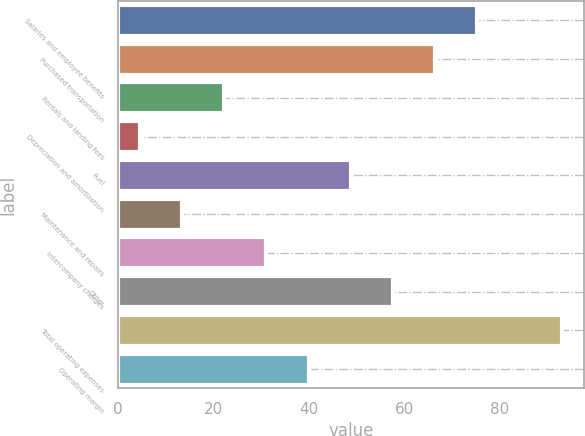Convert chart. <chart><loc_0><loc_0><loc_500><loc_500><bar_chart><fcel>Salaries and employee benefits<fcel>Purchased transportation<fcel>Rentals and landing fees<fcel>Depreciation and amortization<fcel>Fuel<fcel>Maintenance and repairs<fcel>Intercompany charges<fcel>Other<fcel>Total operating expenses<fcel>Operating margin<nl><fcel>75.24<fcel>66.41<fcel>22.26<fcel>4.6<fcel>48.75<fcel>13.43<fcel>31.09<fcel>57.58<fcel>92.9<fcel>39.92<nl></chart> 